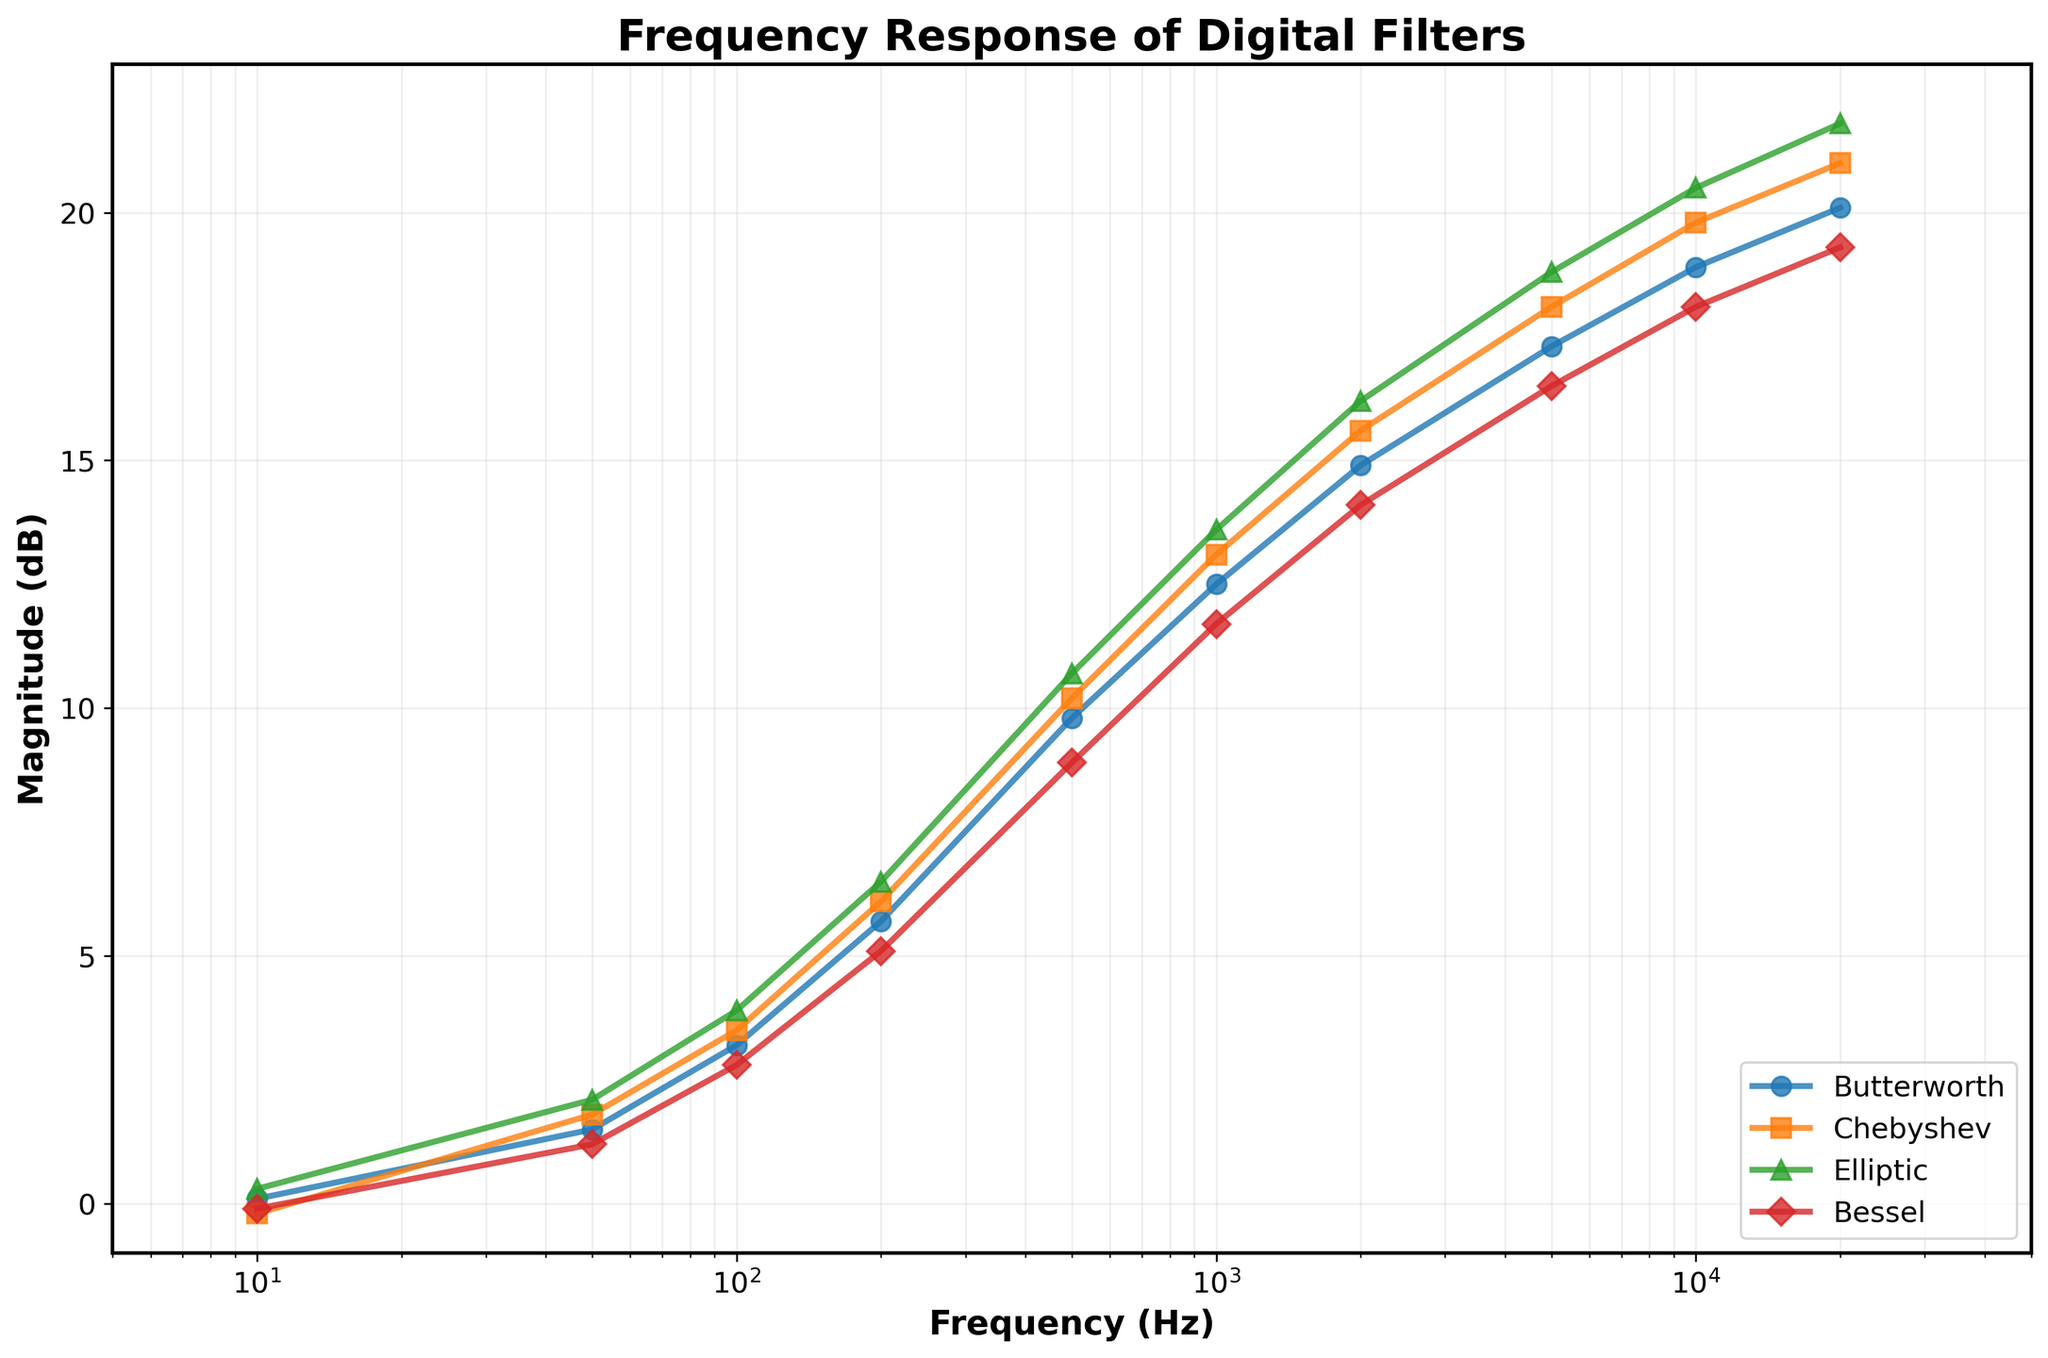Which filter shows the highest magnitude at 100 Hz? From the graph, it can be seen that at 100 Hz, the Elliptic filter has the highest magnitude of 3.9 dB.
Answer: Elliptic Which filter has the lowest magnitude at 500 Hz? At 500 Hz, the Bessel filter has the lowest magnitude, which is 8.9 dB.
Answer: Bessel At 20000 Hz, how much higher is the magnitude of the Elliptic filter compared to the Butterworth filter? At 20000 Hz, the magnitude of the Elliptic filter is 21.8 dB and the Butterworth filter is at 20.1 dB. The difference is 21.8 - 20.1 = 1.7 dB.
Answer: 1.7 dB What is the trend of the magnitude for the Chebyshev filter as the frequency increases from 10 Hz to 20000 Hz? As the frequency increases, the magnitude of the Chebyshev filter also increases, showing a positive correlation between frequency and magnitude.
Answer: Increasing Between the Chebyshev and Bessel filters, which one has a steeper rise in magnitude between 100 Hz and 1000 Hz? The Chebyshev filter rises from around 3.5 dB to 13.1 dB (a rise of 9.6 dB), whereas the Bessel filter rises from approximately 2.8 dB to 11.7 dB (a rise of 8.9 dB) between 100 Hz and 1000 Hz. Thus, the Chebyshev filter has a steeper rise.
Answer: Chebyshev What is the difference in magnitude between the Butterworth and Elliptic filters at 5000 Hz? At 5000 Hz, the Butterworth filter magnitude is 17.3 dB, and the Elliptic filter magnitude is 18.8 dB. The difference is 18.8 - 17.3 = 1.5 dB.
Answer: 1.5 dB Which filter shows the most consistent trend in magnitude as the frequency increases? The Bessel filter shows a more consistent and smoother increasing trend in magnitude as the frequency increases compared to the other filters.
Answer: Bessel Compare the magnitude of the Chebyshev filter at 50 Hz and 200 Hz. How much greater is it at 200 Hz? The magnitude of the Chebyshev filter is 1.8 dB at 50 Hz and 6.1 dB at 200 Hz. The difference is 6.1 - 1.8 = 4.3 dB.
Answer: 4.3 dB How does the magnitude of the Butterworth filter change from 10 Hz to 10000 Hz? The magnitude of the Butterworth filter increases from 0.1 dB at 10 Hz to 18.9 dB at 10000 Hz, indicating a steady rise in magnitude with increasing frequency.
Answer: Increases 